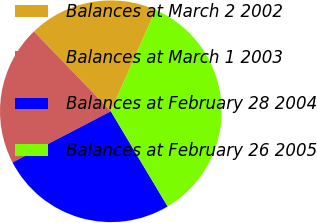Convert chart to OTSL. <chart><loc_0><loc_0><loc_500><loc_500><pie_chart><fcel>Balances at March 2 2002<fcel>Balances at March 1 2003<fcel>Balances at February 28 2004<fcel>Balances at February 26 2005<nl><fcel>18.84%<fcel>20.44%<fcel>25.92%<fcel>34.81%<nl></chart> 